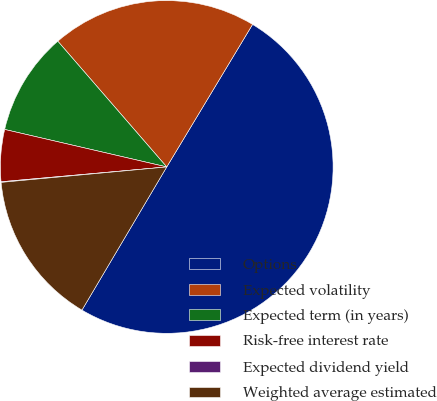Convert chart to OTSL. <chart><loc_0><loc_0><loc_500><loc_500><pie_chart><fcel>Options<fcel>Expected volatility<fcel>Expected term (in years)<fcel>Risk-free interest rate<fcel>Expected dividend yield<fcel>Weighted average estimated<nl><fcel>49.89%<fcel>19.99%<fcel>10.02%<fcel>5.04%<fcel>0.06%<fcel>15.01%<nl></chart> 